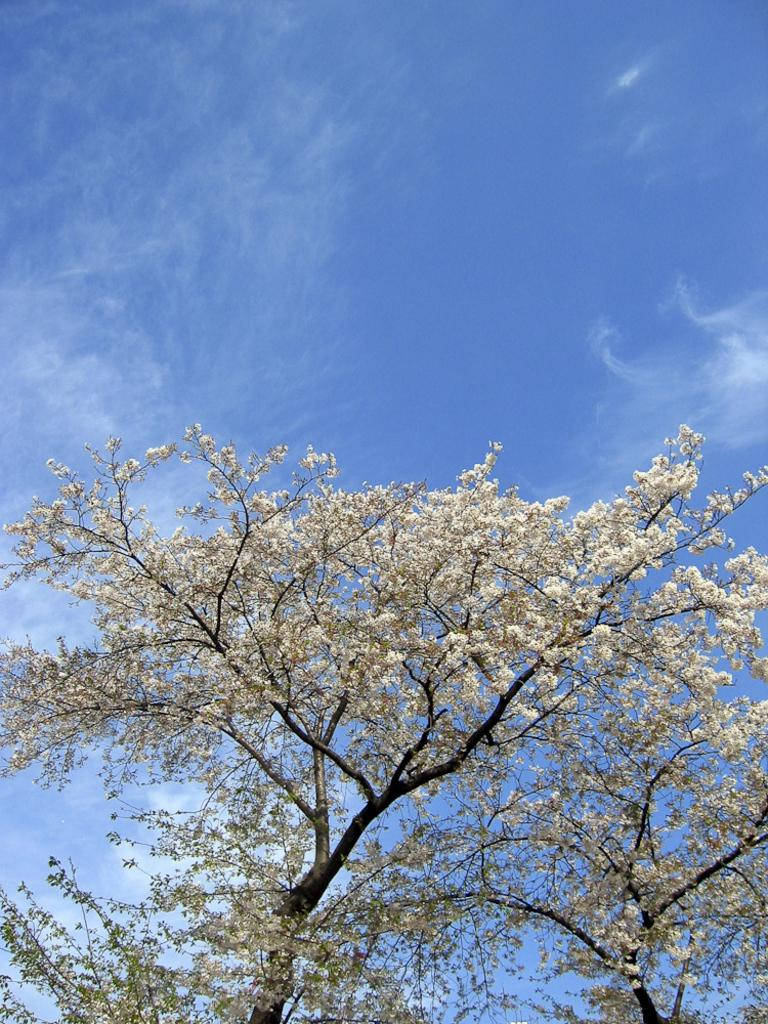What type of plant can be seen in the image? There is a tree in the image. What is special about the tree's appearance? The tree has white flowers on it. What part of the natural environment is visible in the image? The sky is visible in the image. What is the color of the sky in the image? The sky is blue in color. How many secretaries are working in the tree in the image? There are no secretaries present in the image, as it features a tree with white flowers and a blue sky. 